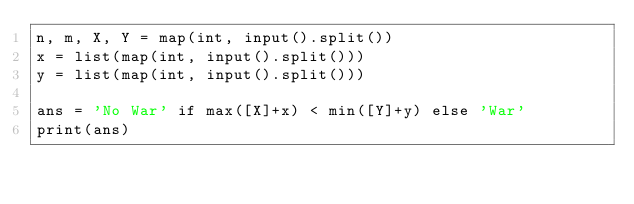<code> <loc_0><loc_0><loc_500><loc_500><_Python_>n, m, X, Y = map(int, input().split())
x = list(map(int, input().split()))
y = list(map(int, input().split()))

ans = 'No War' if max([X]+x) < min([Y]+y) else 'War'
print(ans)
</code> 